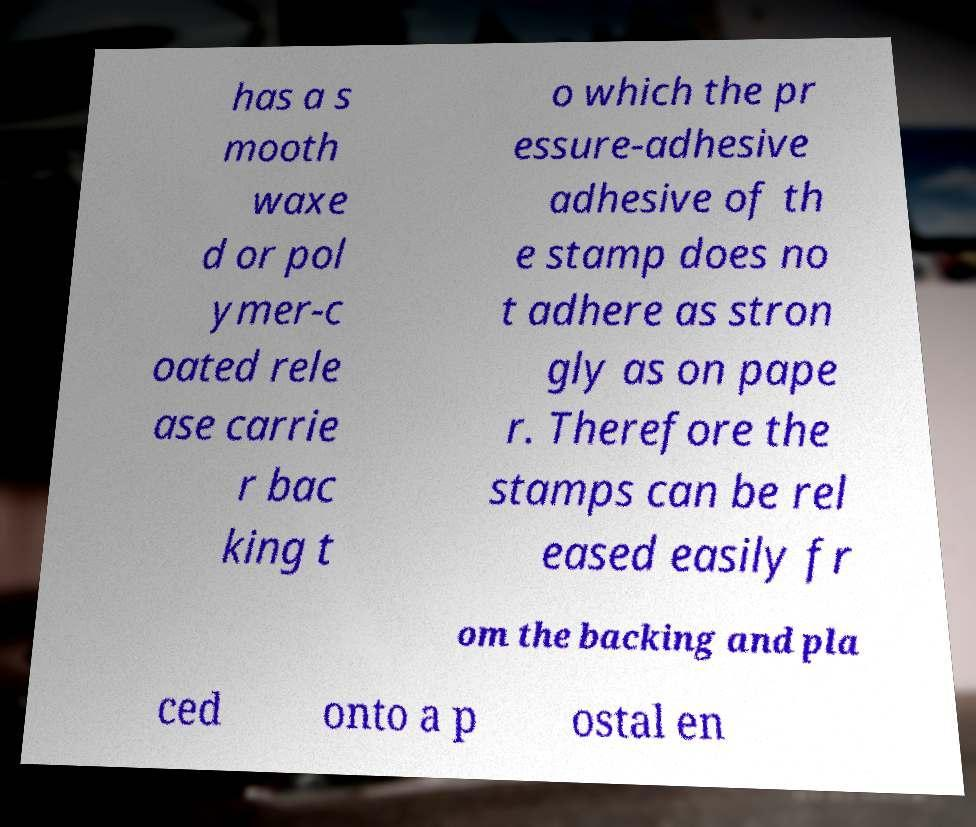For documentation purposes, I need the text within this image transcribed. Could you provide that? has a s mooth waxe d or pol ymer-c oated rele ase carrie r bac king t o which the pr essure-adhesive adhesive of th e stamp does no t adhere as stron gly as on pape r. Therefore the stamps can be rel eased easily fr om the backing and pla ced onto a p ostal en 